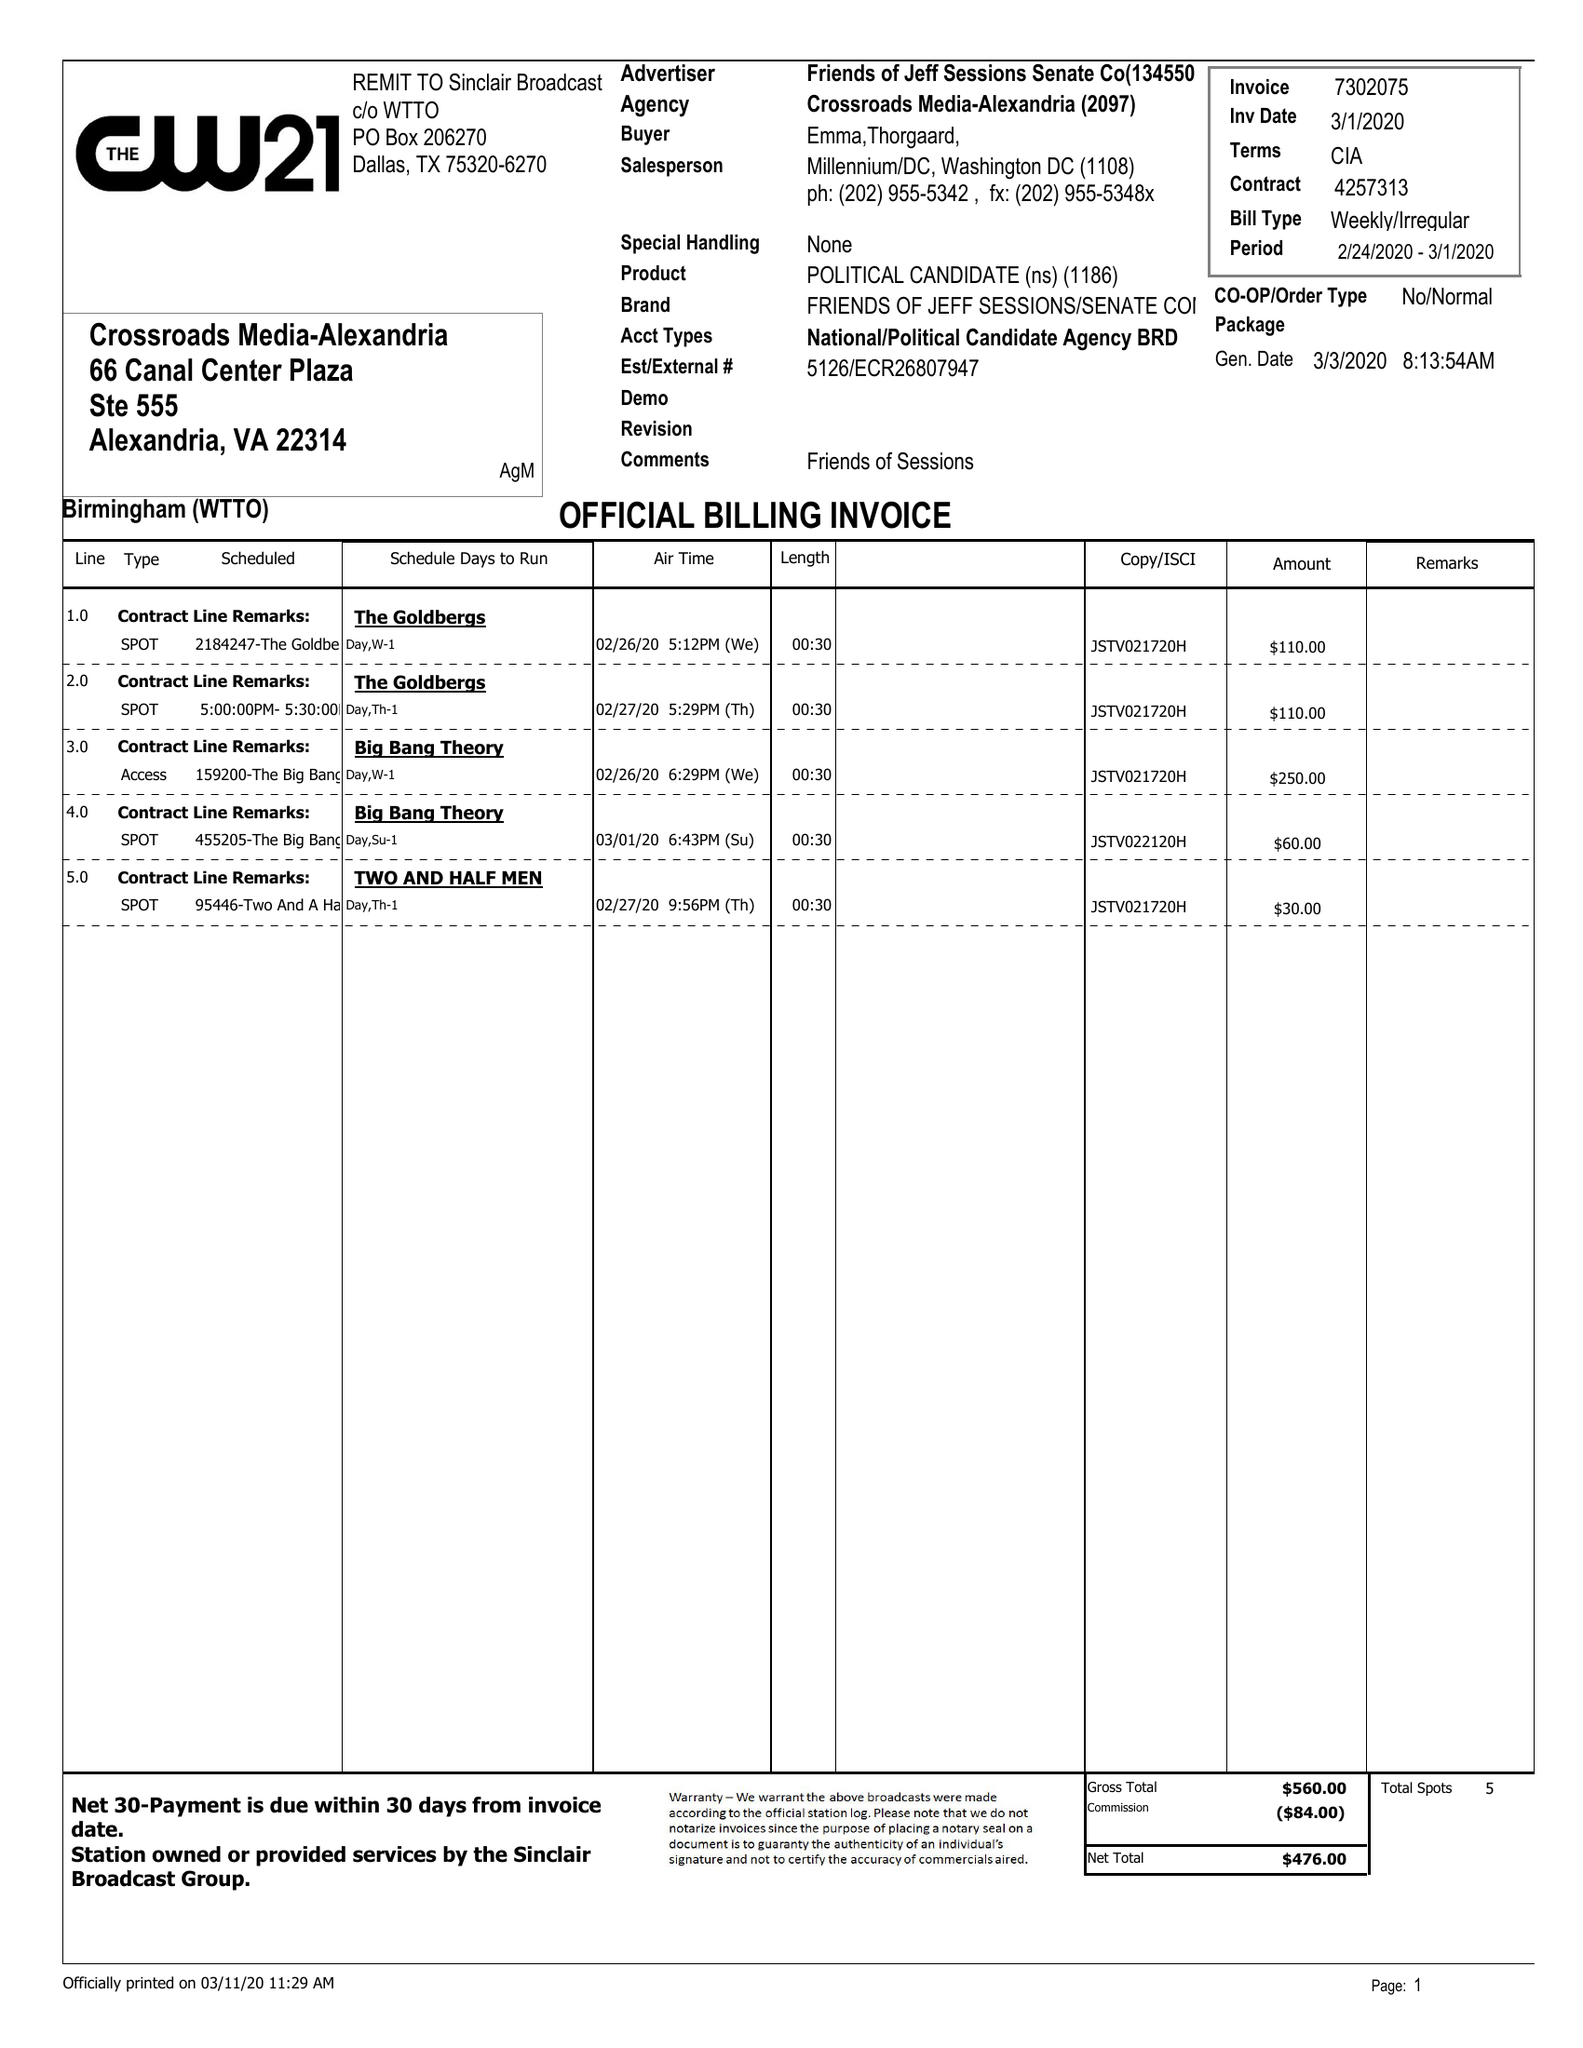What is the value for the gross_amount?
Answer the question using a single word or phrase. 560.00 